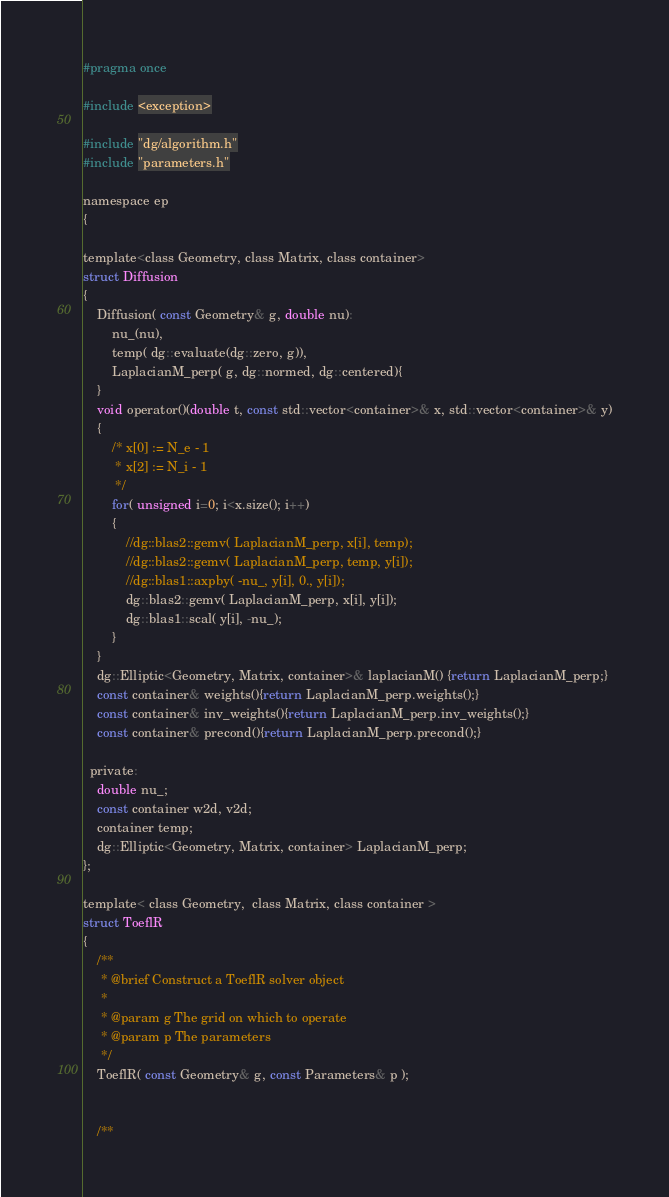Convert code to text. <code><loc_0><loc_0><loc_500><loc_500><_Cuda_>#pragma once

#include <exception>

#include "dg/algorithm.h"
#include "parameters.h"

namespace ep
{

template<class Geometry, class Matrix, class container>
struct Diffusion
{
    Diffusion( const Geometry& g, double nu):
        nu_(nu), 
        temp( dg::evaluate(dg::zero, g)), 
        LaplacianM_perp( g, dg::normed, dg::centered){
    }
    void operator()(double t, const std::vector<container>& x, std::vector<container>& y)
    {
        /* x[0] := N_e - 1
         * x[2] := N_i - 1 
         */
        for( unsigned i=0; i<x.size(); i++)
        {
            //dg::blas2::gemv( LaplacianM_perp, x[i], temp);
            //dg::blas2::gemv( LaplacianM_perp, temp, y[i]);
            //dg::blas1::axpby( -nu_, y[i], 0., y[i]);
            dg::blas2::gemv( LaplacianM_perp, x[i], y[i]);
            dg::blas1::scal( y[i], -nu_);
        }
    }
    dg::Elliptic<Geometry, Matrix, container>& laplacianM() {return LaplacianM_perp;}
    const container& weights(){return LaplacianM_perp.weights();}
    const container& inv_weights(){return LaplacianM_perp.inv_weights();}
    const container& precond(){return LaplacianM_perp.precond();}

  private:
    double nu_;
    const container w2d, v2d;
    container temp;
    dg::Elliptic<Geometry, Matrix, container> LaplacianM_perp;
};

template< class Geometry,  class Matrix, class container >
struct ToeflR
{
    /**
     * @brief Construct a ToeflR solver object
     *
     * @param g The grid on which to operate
     * @param p The parameters
     */
    ToeflR( const Geometry& g, const Parameters& p );


    /**</code> 